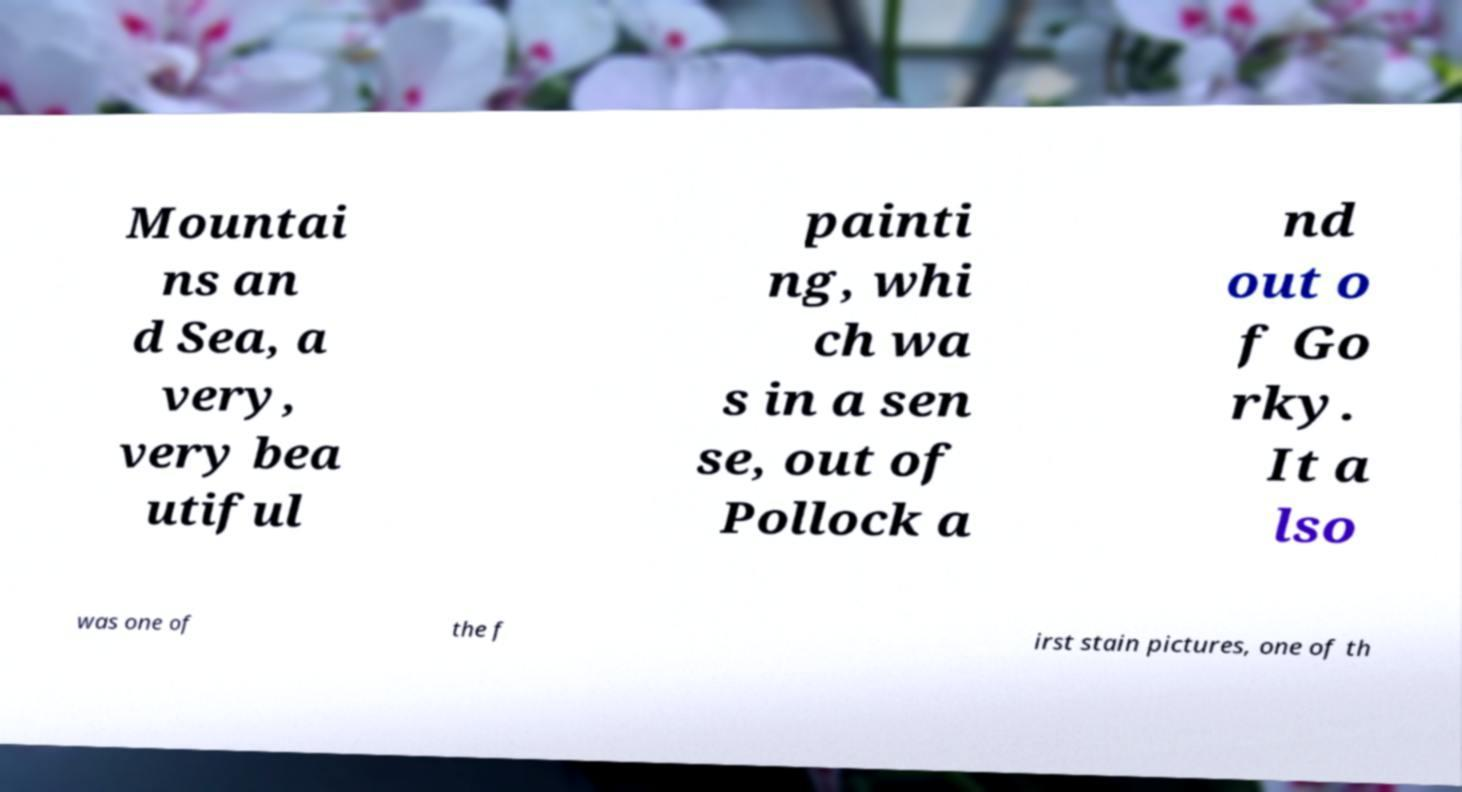There's text embedded in this image that I need extracted. Can you transcribe it verbatim? Mountai ns an d Sea, a very, very bea utiful painti ng, whi ch wa s in a sen se, out of Pollock a nd out o f Go rky. It a lso was one of the f irst stain pictures, one of th 